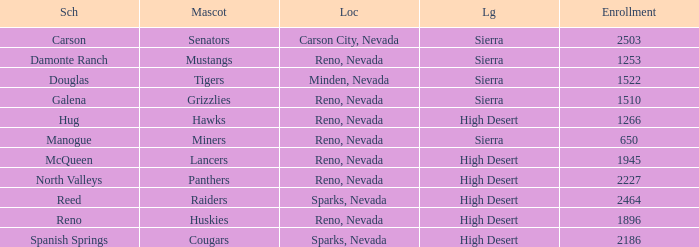What city and state are the miners located in? Reno, Nevada. 